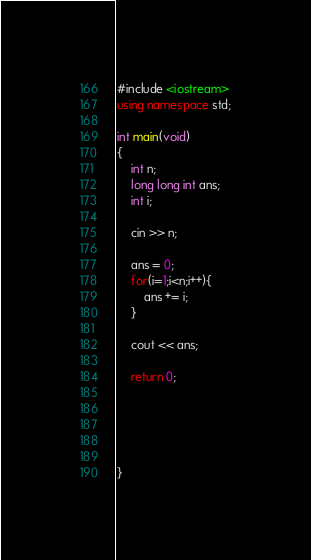<code> <loc_0><loc_0><loc_500><loc_500><_C++_>#include <iostream>
using namespace std;

int main(void)
{
    int n;
    long long int ans;
    int i;

    cin >> n;

    ans = 0;
    for(i=1;i<n;i++){
        ans += i;
    }

    cout << ans;

    return 0;





}
</code> 